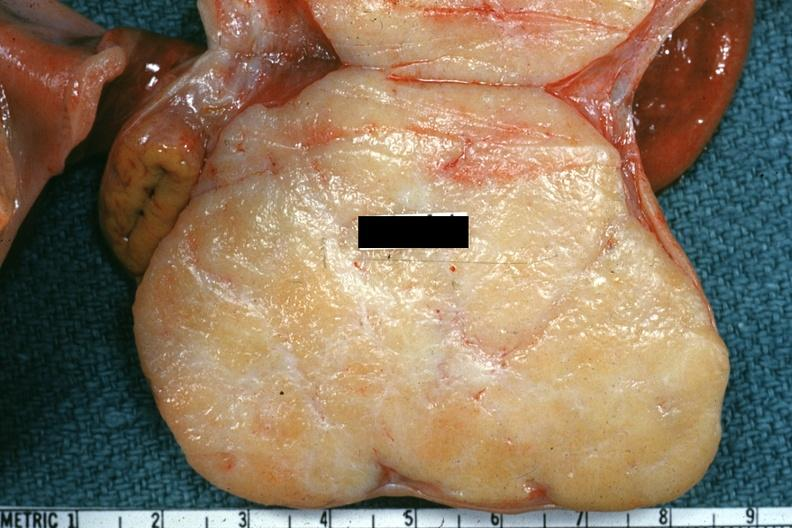does this image show excellent example of brenner tumor?
Answer the question using a single word or phrase. Yes 